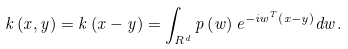Convert formula to latex. <formula><loc_0><loc_0><loc_500><loc_500>k \left ( x , y \right ) = k \left ( x - y \right ) = \int _ { { R } ^ { d } } { p \left ( w \right ) { e } ^ { - i { w } ^ { T } \left ( x - y \right ) } d w } .</formula> 